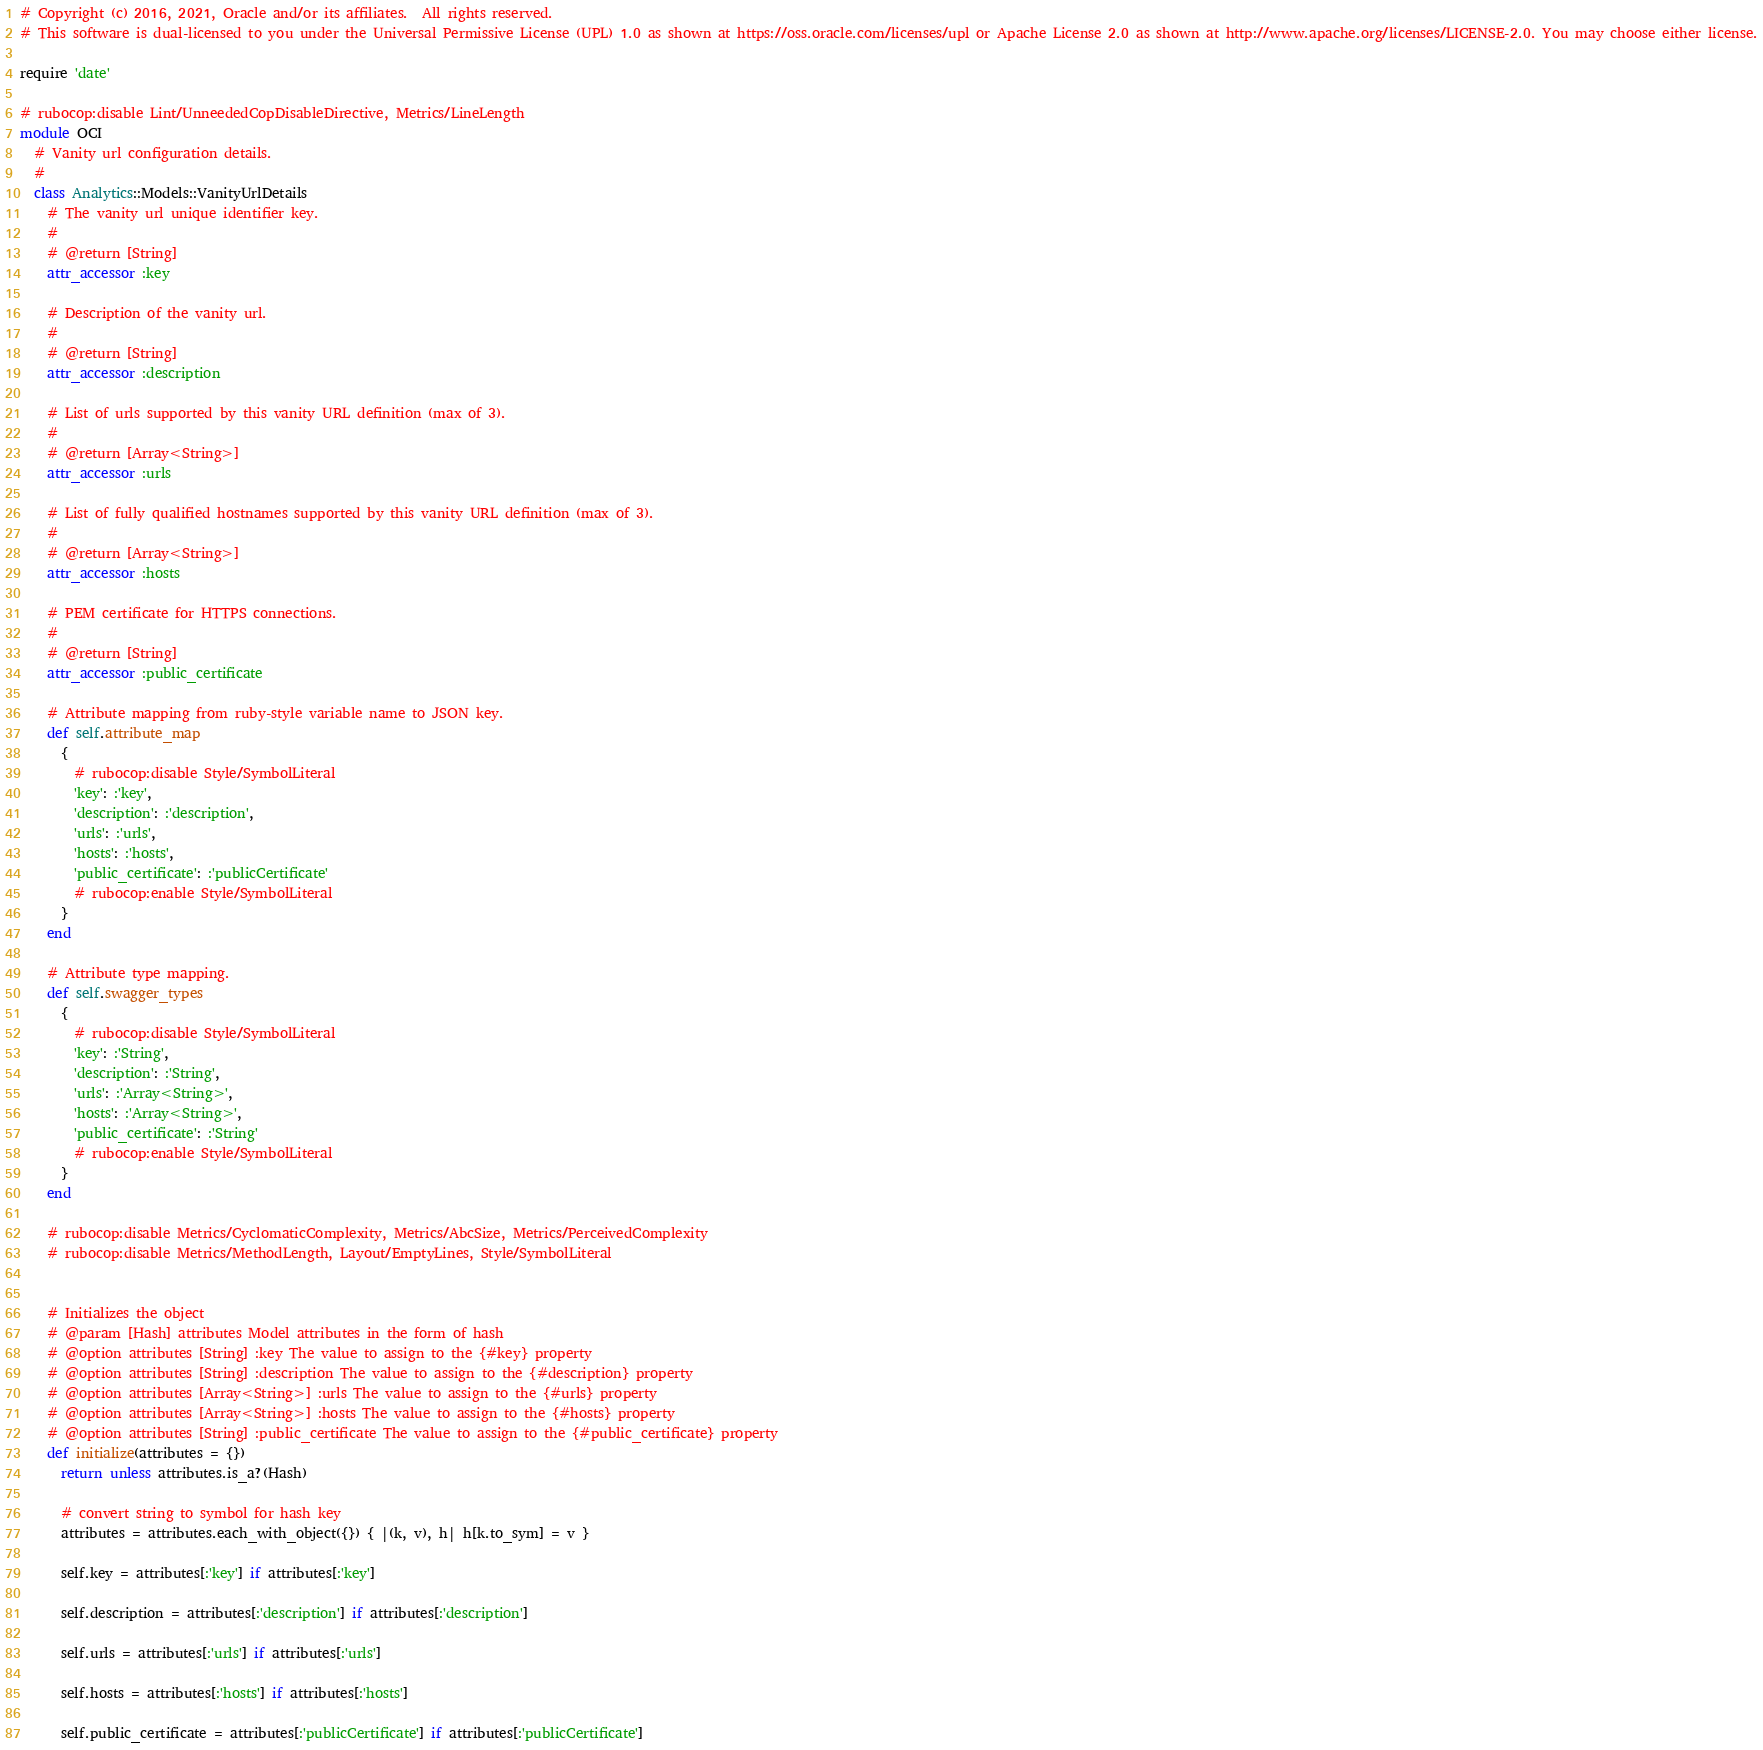Convert code to text. <code><loc_0><loc_0><loc_500><loc_500><_Ruby_># Copyright (c) 2016, 2021, Oracle and/or its affiliates.  All rights reserved.
# This software is dual-licensed to you under the Universal Permissive License (UPL) 1.0 as shown at https://oss.oracle.com/licenses/upl or Apache License 2.0 as shown at http://www.apache.org/licenses/LICENSE-2.0. You may choose either license.

require 'date'

# rubocop:disable Lint/UnneededCopDisableDirective, Metrics/LineLength
module OCI
  # Vanity url configuration details.
  #
  class Analytics::Models::VanityUrlDetails
    # The vanity url unique identifier key.
    #
    # @return [String]
    attr_accessor :key

    # Description of the vanity url.
    #
    # @return [String]
    attr_accessor :description

    # List of urls supported by this vanity URL definition (max of 3).
    #
    # @return [Array<String>]
    attr_accessor :urls

    # List of fully qualified hostnames supported by this vanity URL definition (max of 3).
    #
    # @return [Array<String>]
    attr_accessor :hosts

    # PEM certificate for HTTPS connections.
    #
    # @return [String]
    attr_accessor :public_certificate

    # Attribute mapping from ruby-style variable name to JSON key.
    def self.attribute_map
      {
        # rubocop:disable Style/SymbolLiteral
        'key': :'key',
        'description': :'description',
        'urls': :'urls',
        'hosts': :'hosts',
        'public_certificate': :'publicCertificate'
        # rubocop:enable Style/SymbolLiteral
      }
    end

    # Attribute type mapping.
    def self.swagger_types
      {
        # rubocop:disable Style/SymbolLiteral
        'key': :'String',
        'description': :'String',
        'urls': :'Array<String>',
        'hosts': :'Array<String>',
        'public_certificate': :'String'
        # rubocop:enable Style/SymbolLiteral
      }
    end

    # rubocop:disable Metrics/CyclomaticComplexity, Metrics/AbcSize, Metrics/PerceivedComplexity
    # rubocop:disable Metrics/MethodLength, Layout/EmptyLines, Style/SymbolLiteral


    # Initializes the object
    # @param [Hash] attributes Model attributes in the form of hash
    # @option attributes [String] :key The value to assign to the {#key} property
    # @option attributes [String] :description The value to assign to the {#description} property
    # @option attributes [Array<String>] :urls The value to assign to the {#urls} property
    # @option attributes [Array<String>] :hosts The value to assign to the {#hosts} property
    # @option attributes [String] :public_certificate The value to assign to the {#public_certificate} property
    def initialize(attributes = {})
      return unless attributes.is_a?(Hash)

      # convert string to symbol for hash key
      attributes = attributes.each_with_object({}) { |(k, v), h| h[k.to_sym] = v }

      self.key = attributes[:'key'] if attributes[:'key']

      self.description = attributes[:'description'] if attributes[:'description']

      self.urls = attributes[:'urls'] if attributes[:'urls']

      self.hosts = attributes[:'hosts'] if attributes[:'hosts']

      self.public_certificate = attributes[:'publicCertificate'] if attributes[:'publicCertificate']
</code> 